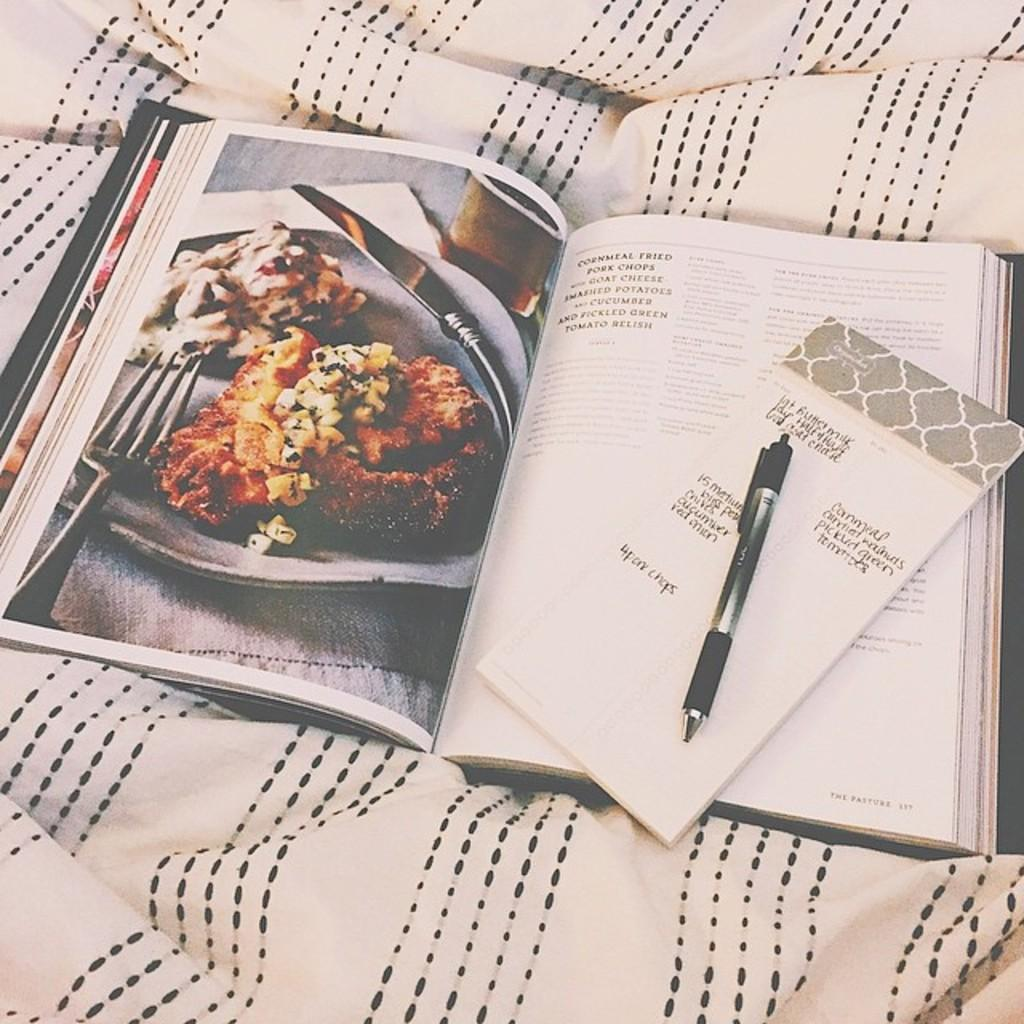What is the main object in the image with a picture on it? There is a book with a picture in the image. What is the other object in the image with text on it? There is a card with text in the image. What writing instrument is present in the image? There is a pen in the image. On what surface are the objects placed? The objects are placed on a cloth surface. How does the person in the image kick the muscle? There is no person or muscle present in the image; it only features a book, a card, a pen, and a cloth surface. 